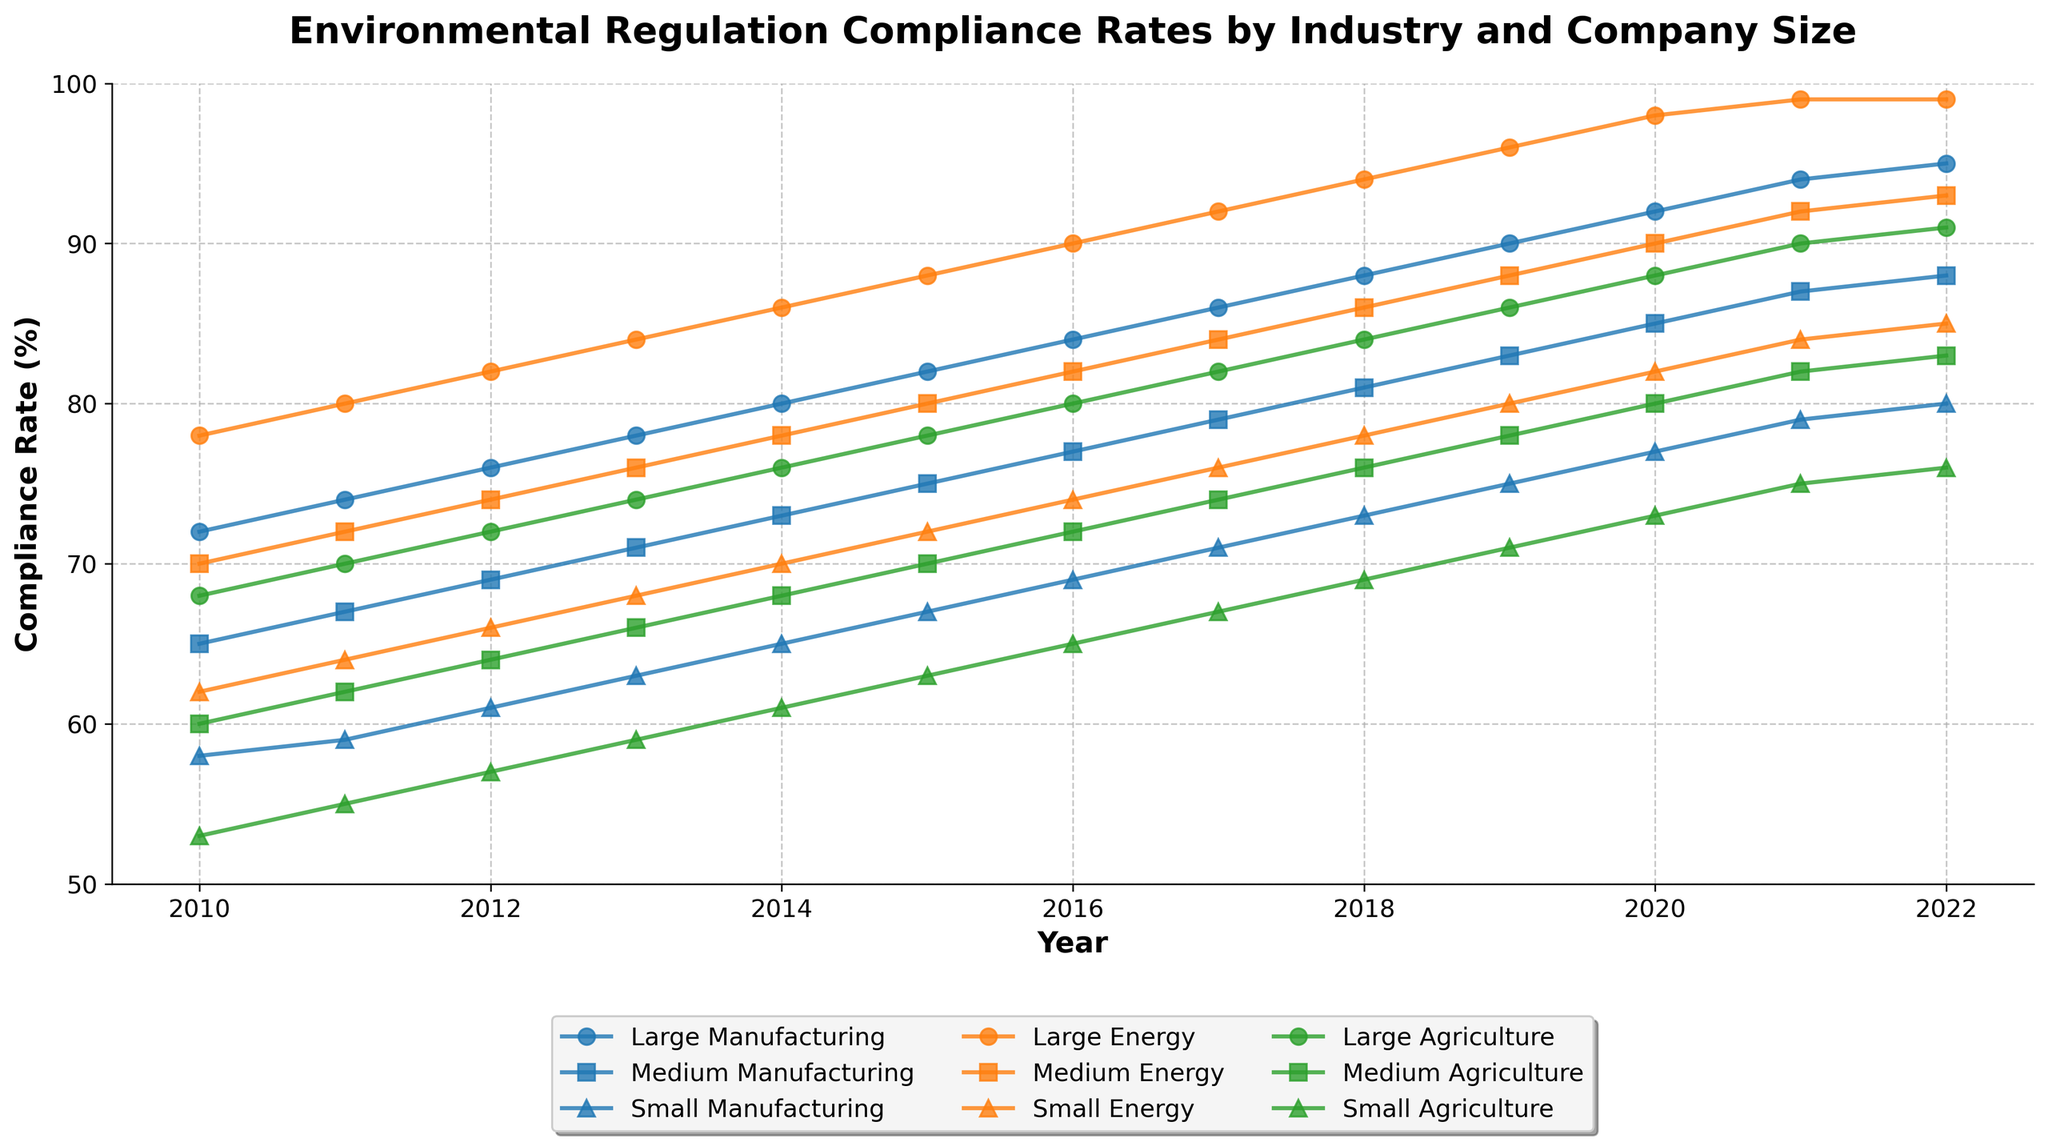What's the compliance rate of Large Manufacturing companies in 2020? Locate the line for Large Manufacturing companies and find the point corresponding to the year 2020.
Answer: 92 Which company size within the Energy industry had the highest compliance rate in 2017? Locate the lines for the Energy industry (Large, Medium, Small). In 2017, Small Energy had a compliance rate of 76, Medium Energy had 84, and Large Energy had 92. The highest is 92.
Answer: Large Energy By how many percentage points did the compliance rate of Medium Agriculture companies increase from 2010 to 2022? Find the compliance rates for Medium Agriculture in 2010 and 2022. The compliance rate was 60 in 2010 and 83 in 2022. The increase is 83 - 60 = 23 percentage points.
Answer: 23 Compare the compliance rates of Small Manufacturing and Small Agriculture companies in 2013. Which one was higher and by how much? Locate the points for Small Manufacturing and Small Agriculture in 2013. Small Manufacturing had a compliance rate of 63, while Small Agriculture had 59. Therefore, Small Manufacturing was higher by 63 - 59 = 4 percentage points.
Answer: Small Manufacturing, 4 What was the average compliance rate of Large companies across all industries in 2018? Find the compliance rates for Large Manufacturing, Large Energy, and Large Agriculture in 2018. The rates are 88, 94, and 84 respectively. The average is (88 + 94 + 84) / 3 = 88.67.
Answer: 88.67 Which industry's compliance rates for Medium-sized companies had the most significant improvement between 2015 and 2021? Compare the changes in compliance rates for Medium Manufacturing (75 to 87), Medium Energy (80 to 92), and Medium Agriculture (70 to 82) from 2015 to 2021. The improvements are 12, 12, and 12 respectively. All industries improved equally.
Answer: Equal for all Did the Small Energy companies ever have a compliance rate higher than Large Manufacturing between 2010 and 2022? Track the compliance rates of Small Energy and Large Manufacturing. Across all years, Small Energy started at 62 in 2010 and only reached 85 by 2022, whereas Large Manufacturing never fell below 72 and reached 95 by 2022. Small Energy was never higher.
Answer: No What year did Medium Manufacturing companies reach a compliance rate of 80% or more? Locate the line for Medium Manufacturing and find the year when the compliance rate first hit at least 80. The rate hit 80 in 2019.
Answer: 2019 How did the compliance rates for Small companies across all industries change from 2018 to 2022? Review compliance rates for Small Manufacturing (73 to 80), Small Energy (78 to 85), and Small Agriculture (69 to 76) from 2018 to 2022. All showed an increase: Small Manufacturing increased by 7, Small Energy by 7, and Small Agriculture by 7 percentage points.
Answer: All increased by 7 What was the sum of compliance rates for all three sizes in the Agriculture industry in 2020? Find compliance rates for Large Agriculture (88), Medium Agriculture (80), and Small Agriculture (73) in 2020, and sum them up: 88 + 80 + 73 = 241.
Answer: 241 